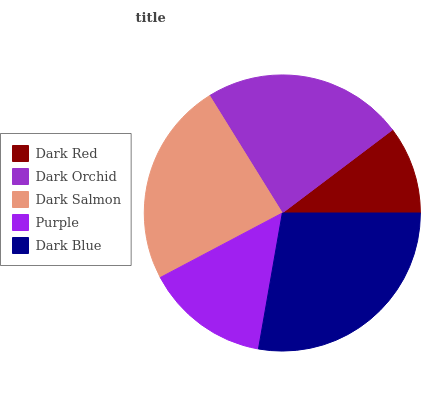Is Dark Red the minimum?
Answer yes or no. Yes. Is Dark Blue the maximum?
Answer yes or no. Yes. Is Dark Orchid the minimum?
Answer yes or no. No. Is Dark Orchid the maximum?
Answer yes or no. No. Is Dark Orchid greater than Dark Red?
Answer yes or no. Yes. Is Dark Red less than Dark Orchid?
Answer yes or no. Yes. Is Dark Red greater than Dark Orchid?
Answer yes or no. No. Is Dark Orchid less than Dark Red?
Answer yes or no. No. Is Dark Orchid the high median?
Answer yes or no. Yes. Is Dark Orchid the low median?
Answer yes or no. Yes. Is Dark Red the high median?
Answer yes or no. No. Is Dark Blue the low median?
Answer yes or no. No. 